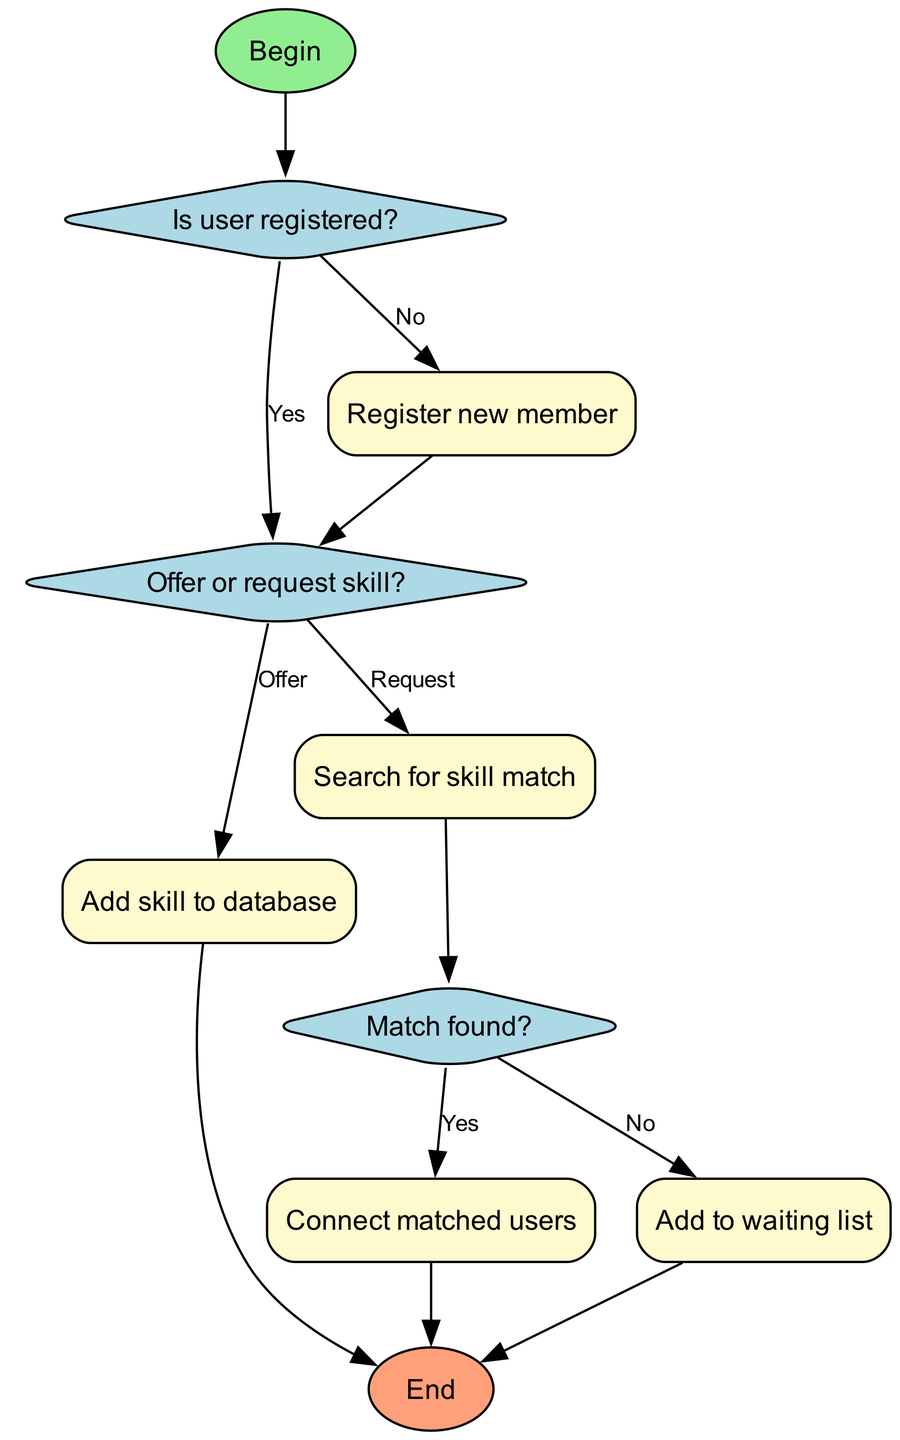What's the first step of the flowchart? The diagram starts with the "Begin" node, leading to the decision of whether the user is registered or not.
Answer: Begin How many decision nodes are there? The diagram features three decision nodes: "Is user registered?", "Offer or request skill?", and "Match found?".
Answer: 3 What happens if the user is not registered? If the user is not registered, the diagram flows to the "Register new member" process. After registration, it goes to the "Offer or request skill?" decision.
Answer: Register new member What workflow follows after a user offers a skill? After selecting "Offer" in the "Offer or request skill?" decision, it leads to the "Add skill to database" process.
Answer: Add skill to database What occurs when a match is found? When a match is found, the flow continues to the "Connect matched users" process before ending the workflow.
Answer: Connect matched users Where do users go if no match is found? If no match is found, the flow directs to "Add to waiting list" process before concluding.
Answer: Add to waiting list What color represents the process nodes? The process nodes are filled with a light yellow color as indicated in the diagram.
Answer: Light yellow Which node follows "Search for skill match"? After "Search for skill match," the flow leads to the "Match found?" decision node for further evaluation.
Answer: Match found? How do you connect the registered user to their skill? A registered user connects to their skill offer through the "Offer or request skill?" node, then it leads to skill addition.
Answer: Offer or request skill What happens at the end of the flowchart? The flowchart concludes with the "End" node after all respective processes or decisions have been followed.
Answer: End 